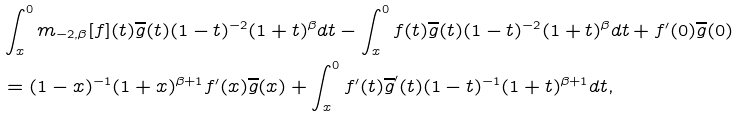<formula> <loc_0><loc_0><loc_500><loc_500>& \int _ { x } ^ { 0 } m _ { - 2 , \beta } [ f ] ( t ) \overline { g } ( t ) ( 1 - t ) ^ { - 2 } ( 1 + t ) ^ { \beta } d t - \int _ { x } ^ { 0 } f ( t ) \overline { g } ( t ) ( 1 - t ) ^ { - 2 } ( 1 + t ) ^ { \beta } d t + f ^ { \prime } ( 0 ) \overline { g } ( 0 ) \\ & = ( 1 - x ) ^ { - 1 } ( 1 + x ) ^ { \beta + 1 } f ^ { \prime } ( x ) \overline { g } ( x ) + \int _ { x } ^ { 0 } f ^ { \prime } ( t ) \overline { g } ^ { \prime } ( t ) ( 1 - t ) ^ { - 1 } ( 1 + t ) ^ { \beta + 1 } d t ,</formula> 